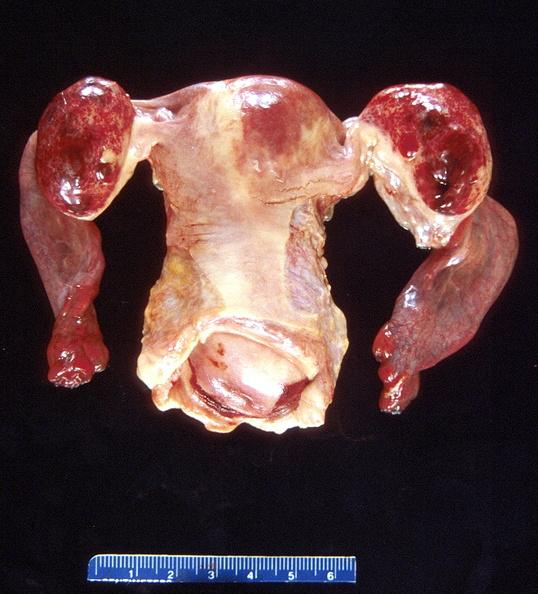does pus in test tube show ovarian cysts, hemorrhagic?
Answer the question using a single word or phrase. No 